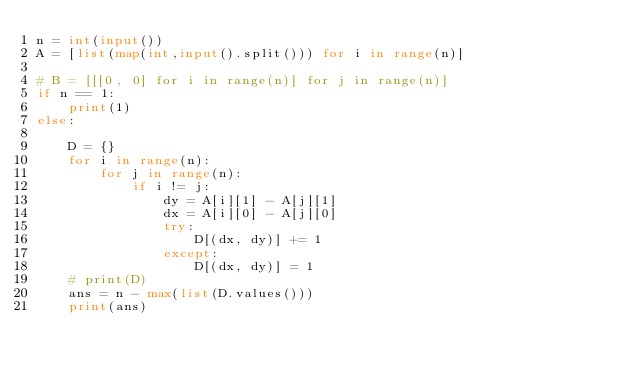<code> <loc_0><loc_0><loc_500><loc_500><_Python_>n = int(input())
A = [list(map(int,input().split())) for i in range(n)]

# B = [[[0, 0] for i in range(n)] for j in range(n)]
if n == 1:
    print(1)
else:

    D = {}
    for i in range(n):
        for j in range(n):
            if i != j:
                dy = A[i][1] - A[j][1]
                dx = A[i][0] - A[j][0]
                try:
                    D[(dx, dy)] += 1
                except:
                    D[(dx, dy)] = 1
    # print(D)
    ans = n - max(list(D.values()))
    print(ans)</code> 